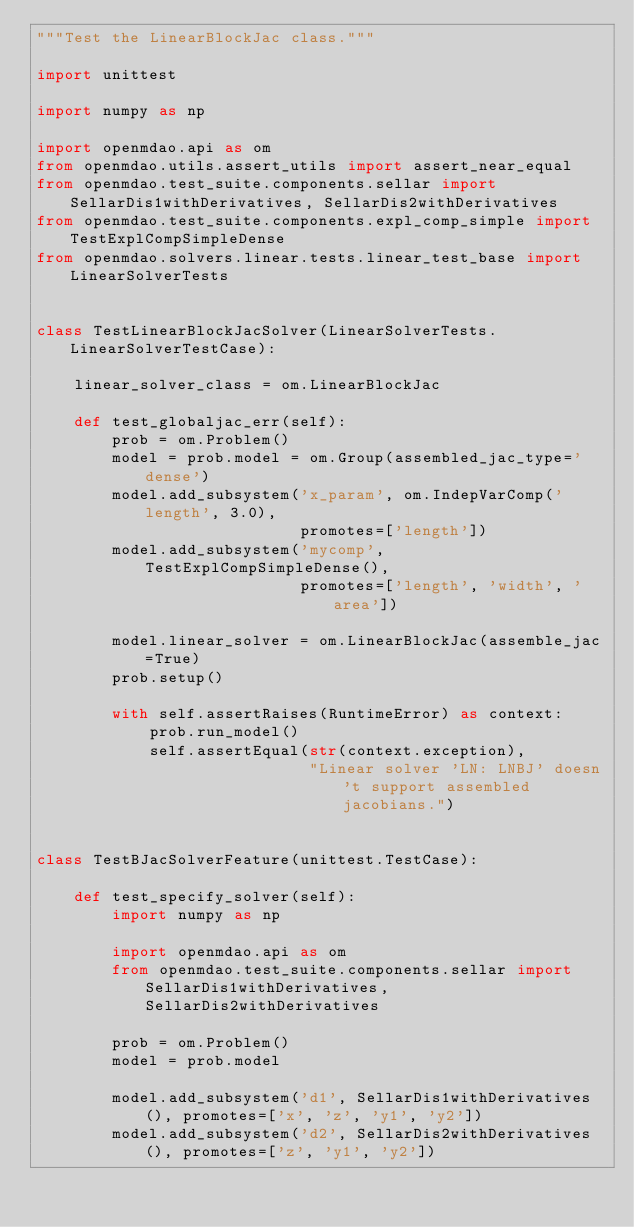<code> <loc_0><loc_0><loc_500><loc_500><_Python_>"""Test the LinearBlockJac class."""

import unittest

import numpy as np

import openmdao.api as om
from openmdao.utils.assert_utils import assert_near_equal
from openmdao.test_suite.components.sellar import SellarDis1withDerivatives, SellarDis2withDerivatives
from openmdao.test_suite.components.expl_comp_simple import TestExplCompSimpleDense
from openmdao.solvers.linear.tests.linear_test_base import LinearSolverTests


class TestLinearBlockJacSolver(LinearSolverTests.LinearSolverTestCase):

    linear_solver_class = om.LinearBlockJac

    def test_globaljac_err(self):
        prob = om.Problem()
        model = prob.model = om.Group(assembled_jac_type='dense')
        model.add_subsystem('x_param', om.IndepVarComp('length', 3.0),
                            promotes=['length'])
        model.add_subsystem('mycomp', TestExplCompSimpleDense(),
                            promotes=['length', 'width', 'area'])

        model.linear_solver = om.LinearBlockJac(assemble_jac=True)
        prob.setup()

        with self.assertRaises(RuntimeError) as context:
            prob.run_model()
            self.assertEqual(str(context.exception),
                             "Linear solver 'LN: LNBJ' doesn't support assembled jacobians.")


class TestBJacSolverFeature(unittest.TestCase):

    def test_specify_solver(self):
        import numpy as np

        import openmdao.api as om
        from openmdao.test_suite.components.sellar import SellarDis1withDerivatives, SellarDis2withDerivatives

        prob = om.Problem()
        model = prob.model

        model.add_subsystem('d1', SellarDis1withDerivatives(), promotes=['x', 'z', 'y1', 'y2'])
        model.add_subsystem('d2', SellarDis2withDerivatives(), promotes=['z', 'y1', 'y2'])
</code> 